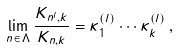<formula> <loc_0><loc_0><loc_500><loc_500>\lim _ { { n } \in { \Lambda } } \frac { K _ { { n } ^ { l } , k } } { K _ { { n } , k } } = \kappa ^ { ( l ) } _ { 1 } \cdots \kappa ^ { ( l ) } _ { k } \, ,</formula> 